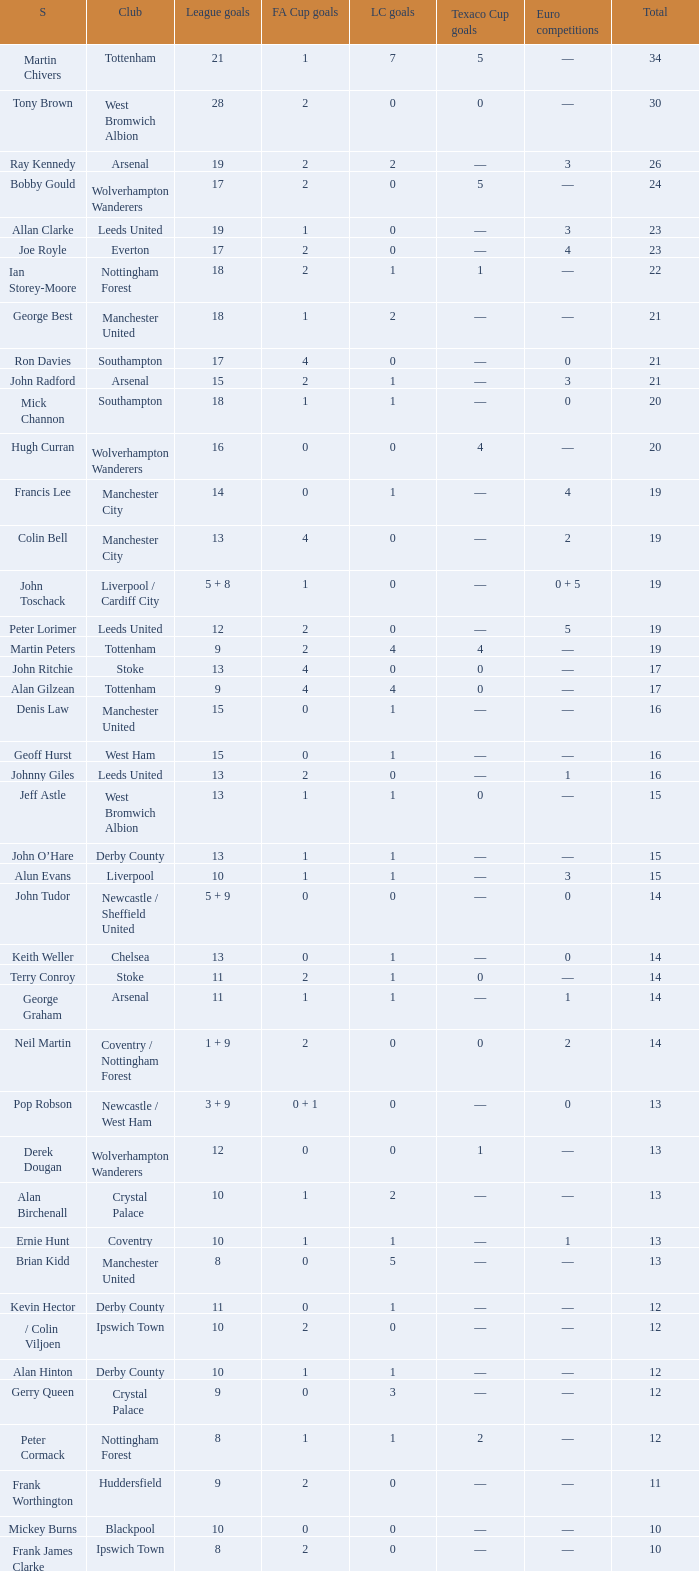What is FA Cup Goals, when Euro Competitions is 1, and when League Goals is 11? 1.0. 